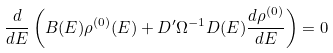Convert formula to latex. <formula><loc_0><loc_0><loc_500><loc_500>\frac { d } { d E } \left ( B ( E ) \rho ^ { ( 0 ) } ( E ) + D ^ { \prime } \Omega ^ { - 1 } D ( E ) \frac { d \rho ^ { ( 0 ) } } { d E } \right ) = 0</formula> 